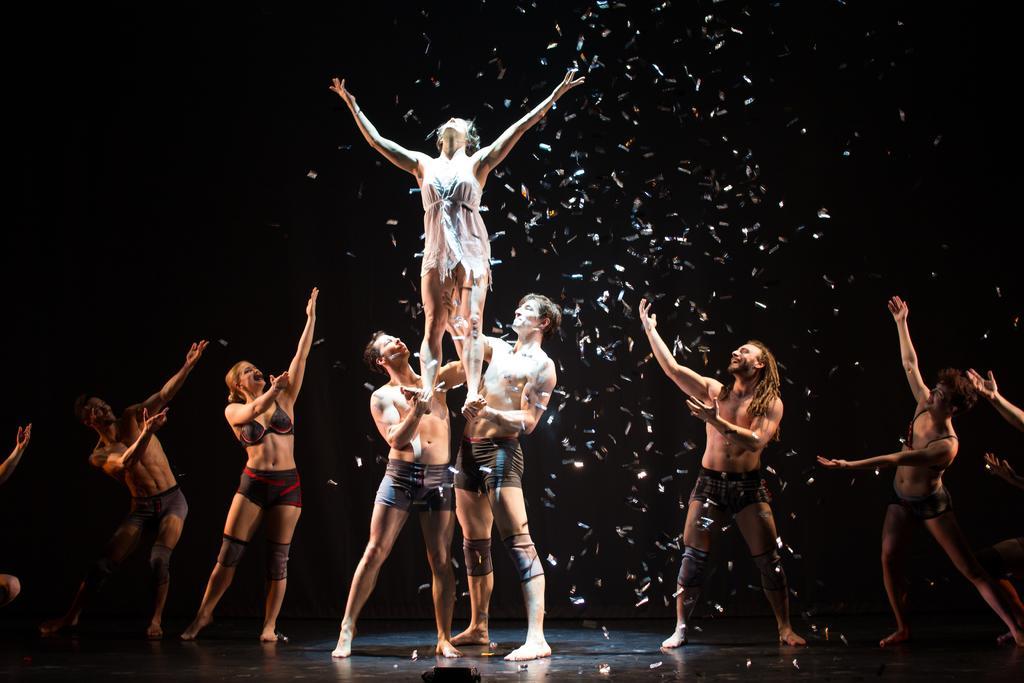How would you summarize this image in a sentence or two? In this image, in the middle, we can see two men are holding another person. On the right side and left side, we can see a group of people dancing. In the background, we can see some papers and black color, at the bottom there is a floor. 